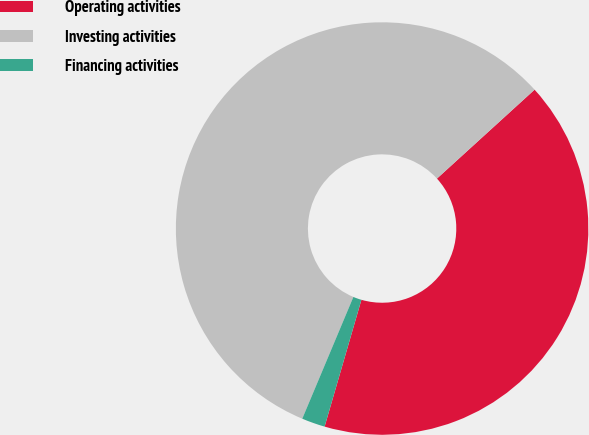Convert chart. <chart><loc_0><loc_0><loc_500><loc_500><pie_chart><fcel>Operating activities<fcel>Investing activities<fcel>Financing activities<nl><fcel>41.25%<fcel>56.91%<fcel>1.83%<nl></chart> 